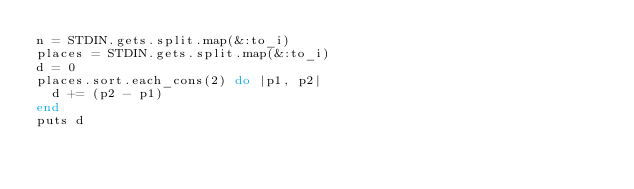Convert code to text. <code><loc_0><loc_0><loc_500><loc_500><_Ruby_>n = STDIN.gets.split.map(&:to_i)
places = STDIN.gets.split.map(&:to_i)
d = 0
places.sort.each_cons(2) do |p1, p2|
  d += (p2 - p1)
end
puts d
</code> 